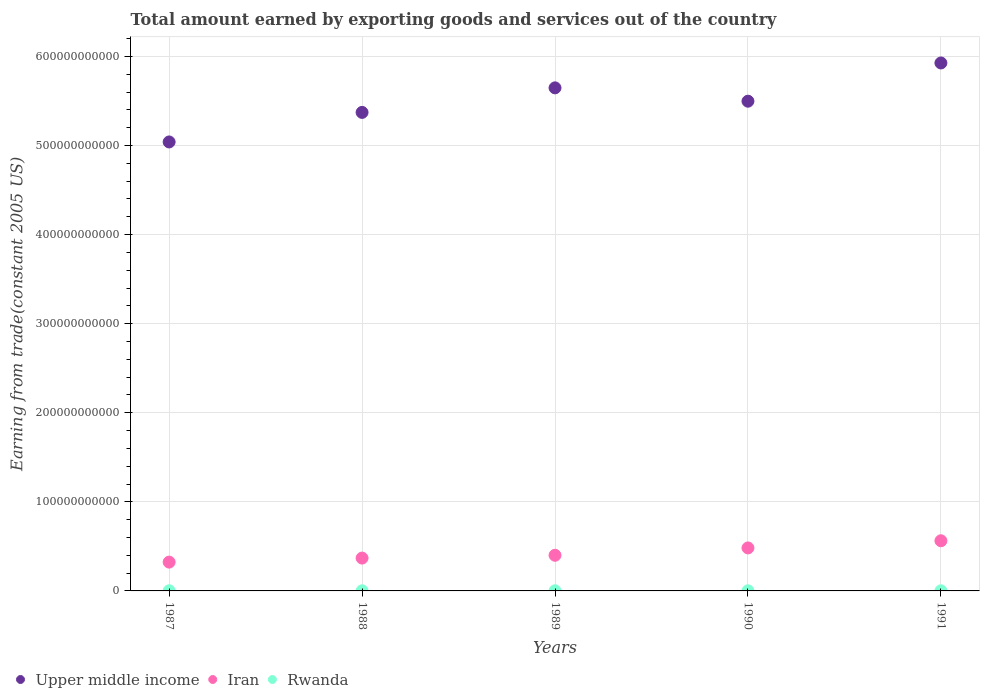How many different coloured dotlines are there?
Provide a succinct answer. 3. What is the total amount earned by exporting goods and services in Upper middle income in 1991?
Give a very brief answer. 5.93e+11. Across all years, what is the maximum total amount earned by exporting goods and services in Iran?
Give a very brief answer. 5.63e+1. Across all years, what is the minimum total amount earned by exporting goods and services in Iran?
Make the answer very short. 3.23e+1. What is the total total amount earned by exporting goods and services in Rwanda in the graph?
Your answer should be compact. 7.23e+08. What is the difference between the total amount earned by exporting goods and services in Upper middle income in 1988 and that in 1989?
Offer a very short reply. -2.75e+1. What is the difference between the total amount earned by exporting goods and services in Iran in 1991 and the total amount earned by exporting goods and services in Rwanda in 1987?
Offer a terse response. 5.61e+1. What is the average total amount earned by exporting goods and services in Iran per year?
Offer a terse response. 4.28e+1. In the year 1989, what is the difference between the total amount earned by exporting goods and services in Upper middle income and total amount earned by exporting goods and services in Rwanda?
Give a very brief answer. 5.65e+11. In how many years, is the total amount earned by exporting goods and services in Upper middle income greater than 320000000000 US$?
Offer a very short reply. 5. What is the ratio of the total amount earned by exporting goods and services in Upper middle income in 1987 to that in 1991?
Your answer should be very brief. 0.85. Is the total amount earned by exporting goods and services in Rwanda in 1989 less than that in 1991?
Your response must be concise. No. What is the difference between the highest and the second highest total amount earned by exporting goods and services in Rwanda?
Give a very brief answer. 2.86e+07. What is the difference between the highest and the lowest total amount earned by exporting goods and services in Upper middle income?
Provide a short and direct response. 8.87e+1. In how many years, is the total amount earned by exporting goods and services in Iran greater than the average total amount earned by exporting goods and services in Iran taken over all years?
Provide a short and direct response. 2. Is it the case that in every year, the sum of the total amount earned by exporting goods and services in Iran and total amount earned by exporting goods and services in Rwanda  is greater than the total amount earned by exporting goods and services in Upper middle income?
Offer a very short reply. No. Does the total amount earned by exporting goods and services in Iran monotonically increase over the years?
Provide a succinct answer. Yes. Is the total amount earned by exporting goods and services in Rwanda strictly greater than the total amount earned by exporting goods and services in Iran over the years?
Keep it short and to the point. No. What is the difference between two consecutive major ticks on the Y-axis?
Provide a short and direct response. 1.00e+11. Are the values on the major ticks of Y-axis written in scientific E-notation?
Give a very brief answer. No. Does the graph contain grids?
Provide a succinct answer. Yes. What is the title of the graph?
Your answer should be very brief. Total amount earned by exporting goods and services out of the country. Does "Haiti" appear as one of the legend labels in the graph?
Your answer should be compact. No. What is the label or title of the X-axis?
Your response must be concise. Years. What is the label or title of the Y-axis?
Make the answer very short. Earning from trade(constant 2005 US). What is the Earning from trade(constant 2005 US) in Upper middle income in 1987?
Give a very brief answer. 5.04e+11. What is the Earning from trade(constant 2005 US) in Iran in 1987?
Offer a terse response. 3.23e+1. What is the Earning from trade(constant 2005 US) of Rwanda in 1987?
Keep it short and to the point. 1.73e+08. What is the Earning from trade(constant 2005 US) in Upper middle income in 1988?
Provide a short and direct response. 5.37e+11. What is the Earning from trade(constant 2005 US) of Iran in 1988?
Your response must be concise. 3.69e+1. What is the Earning from trade(constant 2005 US) in Rwanda in 1988?
Offer a very short reply. 1.37e+08. What is the Earning from trade(constant 2005 US) in Upper middle income in 1989?
Make the answer very short. 5.65e+11. What is the Earning from trade(constant 2005 US) of Iran in 1989?
Your answer should be very brief. 4.00e+1. What is the Earning from trade(constant 2005 US) of Rwanda in 1989?
Provide a succinct answer. 1.44e+08. What is the Earning from trade(constant 2005 US) of Upper middle income in 1990?
Offer a terse response. 5.50e+11. What is the Earning from trade(constant 2005 US) of Iran in 1990?
Offer a terse response. 4.83e+1. What is the Earning from trade(constant 2005 US) of Rwanda in 1990?
Keep it short and to the point. 1.39e+08. What is the Earning from trade(constant 2005 US) of Upper middle income in 1991?
Provide a short and direct response. 5.93e+11. What is the Earning from trade(constant 2005 US) of Iran in 1991?
Offer a very short reply. 5.63e+1. What is the Earning from trade(constant 2005 US) of Rwanda in 1991?
Offer a terse response. 1.29e+08. Across all years, what is the maximum Earning from trade(constant 2005 US) in Upper middle income?
Your response must be concise. 5.93e+11. Across all years, what is the maximum Earning from trade(constant 2005 US) of Iran?
Your response must be concise. 5.63e+1. Across all years, what is the maximum Earning from trade(constant 2005 US) of Rwanda?
Make the answer very short. 1.73e+08. Across all years, what is the minimum Earning from trade(constant 2005 US) in Upper middle income?
Your answer should be very brief. 5.04e+11. Across all years, what is the minimum Earning from trade(constant 2005 US) in Iran?
Keep it short and to the point. 3.23e+1. Across all years, what is the minimum Earning from trade(constant 2005 US) in Rwanda?
Make the answer very short. 1.29e+08. What is the total Earning from trade(constant 2005 US) in Upper middle income in the graph?
Provide a succinct answer. 2.75e+12. What is the total Earning from trade(constant 2005 US) of Iran in the graph?
Your answer should be very brief. 2.14e+11. What is the total Earning from trade(constant 2005 US) in Rwanda in the graph?
Keep it short and to the point. 7.23e+08. What is the difference between the Earning from trade(constant 2005 US) in Upper middle income in 1987 and that in 1988?
Make the answer very short. -3.32e+1. What is the difference between the Earning from trade(constant 2005 US) of Iran in 1987 and that in 1988?
Make the answer very short. -4.53e+09. What is the difference between the Earning from trade(constant 2005 US) of Rwanda in 1987 and that in 1988?
Your answer should be very brief. 3.57e+07. What is the difference between the Earning from trade(constant 2005 US) in Upper middle income in 1987 and that in 1989?
Give a very brief answer. -6.07e+1. What is the difference between the Earning from trade(constant 2005 US) in Iran in 1987 and that in 1989?
Provide a short and direct response. -7.68e+09. What is the difference between the Earning from trade(constant 2005 US) of Rwanda in 1987 and that in 1989?
Ensure brevity in your answer.  2.86e+07. What is the difference between the Earning from trade(constant 2005 US) of Upper middle income in 1987 and that in 1990?
Your answer should be very brief. -4.58e+1. What is the difference between the Earning from trade(constant 2005 US) in Iran in 1987 and that in 1990?
Your response must be concise. -1.59e+1. What is the difference between the Earning from trade(constant 2005 US) in Rwanda in 1987 and that in 1990?
Make the answer very short. 3.37e+07. What is the difference between the Earning from trade(constant 2005 US) of Upper middle income in 1987 and that in 1991?
Offer a terse response. -8.87e+1. What is the difference between the Earning from trade(constant 2005 US) of Iran in 1987 and that in 1991?
Your response must be concise. -2.40e+1. What is the difference between the Earning from trade(constant 2005 US) in Rwanda in 1987 and that in 1991?
Offer a terse response. 4.42e+07. What is the difference between the Earning from trade(constant 2005 US) in Upper middle income in 1988 and that in 1989?
Provide a short and direct response. -2.75e+1. What is the difference between the Earning from trade(constant 2005 US) in Iran in 1988 and that in 1989?
Make the answer very short. -3.14e+09. What is the difference between the Earning from trade(constant 2005 US) of Rwanda in 1988 and that in 1989?
Offer a very short reply. -7.06e+06. What is the difference between the Earning from trade(constant 2005 US) of Upper middle income in 1988 and that in 1990?
Make the answer very short. -1.26e+1. What is the difference between the Earning from trade(constant 2005 US) of Iran in 1988 and that in 1990?
Make the answer very short. -1.14e+1. What is the difference between the Earning from trade(constant 2005 US) of Rwanda in 1988 and that in 1990?
Make the answer very short. -1.98e+06. What is the difference between the Earning from trade(constant 2005 US) of Upper middle income in 1988 and that in 1991?
Provide a succinct answer. -5.55e+1. What is the difference between the Earning from trade(constant 2005 US) of Iran in 1988 and that in 1991?
Give a very brief answer. -1.94e+1. What is the difference between the Earning from trade(constant 2005 US) in Rwanda in 1988 and that in 1991?
Your answer should be very brief. 8.55e+06. What is the difference between the Earning from trade(constant 2005 US) in Upper middle income in 1989 and that in 1990?
Your response must be concise. 1.50e+1. What is the difference between the Earning from trade(constant 2005 US) of Iran in 1989 and that in 1990?
Offer a very short reply. -8.25e+09. What is the difference between the Earning from trade(constant 2005 US) of Rwanda in 1989 and that in 1990?
Your response must be concise. 5.08e+06. What is the difference between the Earning from trade(constant 2005 US) in Upper middle income in 1989 and that in 1991?
Keep it short and to the point. -2.79e+1. What is the difference between the Earning from trade(constant 2005 US) in Iran in 1989 and that in 1991?
Your answer should be very brief. -1.63e+1. What is the difference between the Earning from trade(constant 2005 US) of Rwanda in 1989 and that in 1991?
Provide a short and direct response. 1.56e+07. What is the difference between the Earning from trade(constant 2005 US) in Upper middle income in 1990 and that in 1991?
Your response must be concise. -4.29e+1. What is the difference between the Earning from trade(constant 2005 US) of Iran in 1990 and that in 1991?
Provide a succinct answer. -8.04e+09. What is the difference between the Earning from trade(constant 2005 US) in Rwanda in 1990 and that in 1991?
Provide a short and direct response. 1.05e+07. What is the difference between the Earning from trade(constant 2005 US) in Upper middle income in 1987 and the Earning from trade(constant 2005 US) in Iran in 1988?
Keep it short and to the point. 4.67e+11. What is the difference between the Earning from trade(constant 2005 US) of Upper middle income in 1987 and the Earning from trade(constant 2005 US) of Rwanda in 1988?
Ensure brevity in your answer.  5.04e+11. What is the difference between the Earning from trade(constant 2005 US) of Iran in 1987 and the Earning from trade(constant 2005 US) of Rwanda in 1988?
Provide a succinct answer. 3.22e+1. What is the difference between the Earning from trade(constant 2005 US) in Upper middle income in 1987 and the Earning from trade(constant 2005 US) in Iran in 1989?
Provide a short and direct response. 4.64e+11. What is the difference between the Earning from trade(constant 2005 US) in Upper middle income in 1987 and the Earning from trade(constant 2005 US) in Rwanda in 1989?
Keep it short and to the point. 5.04e+11. What is the difference between the Earning from trade(constant 2005 US) of Iran in 1987 and the Earning from trade(constant 2005 US) of Rwanda in 1989?
Provide a short and direct response. 3.22e+1. What is the difference between the Earning from trade(constant 2005 US) in Upper middle income in 1987 and the Earning from trade(constant 2005 US) in Iran in 1990?
Ensure brevity in your answer.  4.56e+11. What is the difference between the Earning from trade(constant 2005 US) in Upper middle income in 1987 and the Earning from trade(constant 2005 US) in Rwanda in 1990?
Your answer should be compact. 5.04e+11. What is the difference between the Earning from trade(constant 2005 US) of Iran in 1987 and the Earning from trade(constant 2005 US) of Rwanda in 1990?
Keep it short and to the point. 3.22e+1. What is the difference between the Earning from trade(constant 2005 US) in Upper middle income in 1987 and the Earning from trade(constant 2005 US) in Iran in 1991?
Provide a succinct answer. 4.48e+11. What is the difference between the Earning from trade(constant 2005 US) in Upper middle income in 1987 and the Earning from trade(constant 2005 US) in Rwanda in 1991?
Your response must be concise. 5.04e+11. What is the difference between the Earning from trade(constant 2005 US) of Iran in 1987 and the Earning from trade(constant 2005 US) of Rwanda in 1991?
Your response must be concise. 3.22e+1. What is the difference between the Earning from trade(constant 2005 US) in Upper middle income in 1988 and the Earning from trade(constant 2005 US) in Iran in 1989?
Offer a very short reply. 4.97e+11. What is the difference between the Earning from trade(constant 2005 US) in Upper middle income in 1988 and the Earning from trade(constant 2005 US) in Rwanda in 1989?
Give a very brief answer. 5.37e+11. What is the difference between the Earning from trade(constant 2005 US) in Iran in 1988 and the Earning from trade(constant 2005 US) in Rwanda in 1989?
Give a very brief answer. 3.67e+1. What is the difference between the Earning from trade(constant 2005 US) in Upper middle income in 1988 and the Earning from trade(constant 2005 US) in Iran in 1990?
Make the answer very short. 4.89e+11. What is the difference between the Earning from trade(constant 2005 US) of Upper middle income in 1988 and the Earning from trade(constant 2005 US) of Rwanda in 1990?
Offer a very short reply. 5.37e+11. What is the difference between the Earning from trade(constant 2005 US) in Iran in 1988 and the Earning from trade(constant 2005 US) in Rwanda in 1990?
Your answer should be very brief. 3.67e+1. What is the difference between the Earning from trade(constant 2005 US) of Upper middle income in 1988 and the Earning from trade(constant 2005 US) of Iran in 1991?
Your answer should be very brief. 4.81e+11. What is the difference between the Earning from trade(constant 2005 US) in Upper middle income in 1988 and the Earning from trade(constant 2005 US) in Rwanda in 1991?
Give a very brief answer. 5.37e+11. What is the difference between the Earning from trade(constant 2005 US) of Iran in 1988 and the Earning from trade(constant 2005 US) of Rwanda in 1991?
Make the answer very short. 3.67e+1. What is the difference between the Earning from trade(constant 2005 US) of Upper middle income in 1989 and the Earning from trade(constant 2005 US) of Iran in 1990?
Your answer should be compact. 5.16e+11. What is the difference between the Earning from trade(constant 2005 US) in Upper middle income in 1989 and the Earning from trade(constant 2005 US) in Rwanda in 1990?
Ensure brevity in your answer.  5.65e+11. What is the difference between the Earning from trade(constant 2005 US) in Iran in 1989 and the Earning from trade(constant 2005 US) in Rwanda in 1990?
Ensure brevity in your answer.  3.99e+1. What is the difference between the Earning from trade(constant 2005 US) in Upper middle income in 1989 and the Earning from trade(constant 2005 US) in Iran in 1991?
Give a very brief answer. 5.08e+11. What is the difference between the Earning from trade(constant 2005 US) of Upper middle income in 1989 and the Earning from trade(constant 2005 US) of Rwanda in 1991?
Give a very brief answer. 5.65e+11. What is the difference between the Earning from trade(constant 2005 US) in Iran in 1989 and the Earning from trade(constant 2005 US) in Rwanda in 1991?
Provide a succinct answer. 3.99e+1. What is the difference between the Earning from trade(constant 2005 US) of Upper middle income in 1990 and the Earning from trade(constant 2005 US) of Iran in 1991?
Make the answer very short. 4.93e+11. What is the difference between the Earning from trade(constant 2005 US) of Upper middle income in 1990 and the Earning from trade(constant 2005 US) of Rwanda in 1991?
Provide a short and direct response. 5.50e+11. What is the difference between the Earning from trade(constant 2005 US) of Iran in 1990 and the Earning from trade(constant 2005 US) of Rwanda in 1991?
Make the answer very short. 4.81e+1. What is the average Earning from trade(constant 2005 US) of Upper middle income per year?
Ensure brevity in your answer.  5.50e+11. What is the average Earning from trade(constant 2005 US) of Iran per year?
Ensure brevity in your answer.  4.28e+1. What is the average Earning from trade(constant 2005 US) in Rwanda per year?
Provide a succinct answer. 1.45e+08. In the year 1987, what is the difference between the Earning from trade(constant 2005 US) of Upper middle income and Earning from trade(constant 2005 US) of Iran?
Your answer should be compact. 4.72e+11. In the year 1987, what is the difference between the Earning from trade(constant 2005 US) in Upper middle income and Earning from trade(constant 2005 US) in Rwanda?
Your answer should be very brief. 5.04e+11. In the year 1987, what is the difference between the Earning from trade(constant 2005 US) of Iran and Earning from trade(constant 2005 US) of Rwanda?
Your response must be concise. 3.22e+1. In the year 1988, what is the difference between the Earning from trade(constant 2005 US) in Upper middle income and Earning from trade(constant 2005 US) in Iran?
Give a very brief answer. 5.00e+11. In the year 1988, what is the difference between the Earning from trade(constant 2005 US) in Upper middle income and Earning from trade(constant 2005 US) in Rwanda?
Ensure brevity in your answer.  5.37e+11. In the year 1988, what is the difference between the Earning from trade(constant 2005 US) of Iran and Earning from trade(constant 2005 US) of Rwanda?
Give a very brief answer. 3.67e+1. In the year 1989, what is the difference between the Earning from trade(constant 2005 US) in Upper middle income and Earning from trade(constant 2005 US) in Iran?
Your answer should be very brief. 5.25e+11. In the year 1989, what is the difference between the Earning from trade(constant 2005 US) in Upper middle income and Earning from trade(constant 2005 US) in Rwanda?
Your response must be concise. 5.65e+11. In the year 1989, what is the difference between the Earning from trade(constant 2005 US) of Iran and Earning from trade(constant 2005 US) of Rwanda?
Keep it short and to the point. 3.99e+1. In the year 1990, what is the difference between the Earning from trade(constant 2005 US) in Upper middle income and Earning from trade(constant 2005 US) in Iran?
Give a very brief answer. 5.01e+11. In the year 1990, what is the difference between the Earning from trade(constant 2005 US) in Upper middle income and Earning from trade(constant 2005 US) in Rwanda?
Give a very brief answer. 5.50e+11. In the year 1990, what is the difference between the Earning from trade(constant 2005 US) in Iran and Earning from trade(constant 2005 US) in Rwanda?
Your response must be concise. 4.81e+1. In the year 1991, what is the difference between the Earning from trade(constant 2005 US) in Upper middle income and Earning from trade(constant 2005 US) in Iran?
Offer a terse response. 5.36e+11. In the year 1991, what is the difference between the Earning from trade(constant 2005 US) in Upper middle income and Earning from trade(constant 2005 US) in Rwanda?
Your answer should be compact. 5.92e+11. In the year 1991, what is the difference between the Earning from trade(constant 2005 US) in Iran and Earning from trade(constant 2005 US) in Rwanda?
Keep it short and to the point. 5.62e+1. What is the ratio of the Earning from trade(constant 2005 US) of Upper middle income in 1987 to that in 1988?
Provide a short and direct response. 0.94. What is the ratio of the Earning from trade(constant 2005 US) in Iran in 1987 to that in 1988?
Offer a terse response. 0.88. What is the ratio of the Earning from trade(constant 2005 US) in Rwanda in 1987 to that in 1988?
Keep it short and to the point. 1.26. What is the ratio of the Earning from trade(constant 2005 US) in Upper middle income in 1987 to that in 1989?
Your response must be concise. 0.89. What is the ratio of the Earning from trade(constant 2005 US) of Iran in 1987 to that in 1989?
Offer a very short reply. 0.81. What is the ratio of the Earning from trade(constant 2005 US) of Rwanda in 1987 to that in 1989?
Give a very brief answer. 1.2. What is the ratio of the Earning from trade(constant 2005 US) of Upper middle income in 1987 to that in 1990?
Your answer should be very brief. 0.92. What is the ratio of the Earning from trade(constant 2005 US) in Iran in 1987 to that in 1990?
Your answer should be compact. 0.67. What is the ratio of the Earning from trade(constant 2005 US) in Rwanda in 1987 to that in 1990?
Provide a short and direct response. 1.24. What is the ratio of the Earning from trade(constant 2005 US) of Upper middle income in 1987 to that in 1991?
Give a very brief answer. 0.85. What is the ratio of the Earning from trade(constant 2005 US) in Iran in 1987 to that in 1991?
Offer a terse response. 0.57. What is the ratio of the Earning from trade(constant 2005 US) of Rwanda in 1987 to that in 1991?
Your answer should be very brief. 1.34. What is the ratio of the Earning from trade(constant 2005 US) in Upper middle income in 1988 to that in 1989?
Provide a succinct answer. 0.95. What is the ratio of the Earning from trade(constant 2005 US) of Iran in 1988 to that in 1989?
Your answer should be very brief. 0.92. What is the ratio of the Earning from trade(constant 2005 US) in Rwanda in 1988 to that in 1989?
Keep it short and to the point. 0.95. What is the ratio of the Earning from trade(constant 2005 US) in Upper middle income in 1988 to that in 1990?
Ensure brevity in your answer.  0.98. What is the ratio of the Earning from trade(constant 2005 US) in Iran in 1988 to that in 1990?
Provide a short and direct response. 0.76. What is the ratio of the Earning from trade(constant 2005 US) in Rwanda in 1988 to that in 1990?
Provide a short and direct response. 0.99. What is the ratio of the Earning from trade(constant 2005 US) in Upper middle income in 1988 to that in 1991?
Your answer should be very brief. 0.91. What is the ratio of the Earning from trade(constant 2005 US) of Iran in 1988 to that in 1991?
Keep it short and to the point. 0.65. What is the ratio of the Earning from trade(constant 2005 US) of Rwanda in 1988 to that in 1991?
Your answer should be compact. 1.07. What is the ratio of the Earning from trade(constant 2005 US) in Upper middle income in 1989 to that in 1990?
Your answer should be compact. 1.03. What is the ratio of the Earning from trade(constant 2005 US) in Iran in 1989 to that in 1990?
Provide a short and direct response. 0.83. What is the ratio of the Earning from trade(constant 2005 US) of Rwanda in 1989 to that in 1990?
Make the answer very short. 1.04. What is the ratio of the Earning from trade(constant 2005 US) of Upper middle income in 1989 to that in 1991?
Keep it short and to the point. 0.95. What is the ratio of the Earning from trade(constant 2005 US) of Iran in 1989 to that in 1991?
Your answer should be very brief. 0.71. What is the ratio of the Earning from trade(constant 2005 US) of Rwanda in 1989 to that in 1991?
Offer a very short reply. 1.12. What is the ratio of the Earning from trade(constant 2005 US) in Upper middle income in 1990 to that in 1991?
Offer a very short reply. 0.93. What is the ratio of the Earning from trade(constant 2005 US) of Iran in 1990 to that in 1991?
Ensure brevity in your answer.  0.86. What is the ratio of the Earning from trade(constant 2005 US) in Rwanda in 1990 to that in 1991?
Give a very brief answer. 1.08. What is the difference between the highest and the second highest Earning from trade(constant 2005 US) of Upper middle income?
Keep it short and to the point. 2.79e+1. What is the difference between the highest and the second highest Earning from trade(constant 2005 US) in Iran?
Offer a very short reply. 8.04e+09. What is the difference between the highest and the second highest Earning from trade(constant 2005 US) in Rwanda?
Your response must be concise. 2.86e+07. What is the difference between the highest and the lowest Earning from trade(constant 2005 US) in Upper middle income?
Your answer should be compact. 8.87e+1. What is the difference between the highest and the lowest Earning from trade(constant 2005 US) in Iran?
Provide a short and direct response. 2.40e+1. What is the difference between the highest and the lowest Earning from trade(constant 2005 US) in Rwanda?
Give a very brief answer. 4.42e+07. 